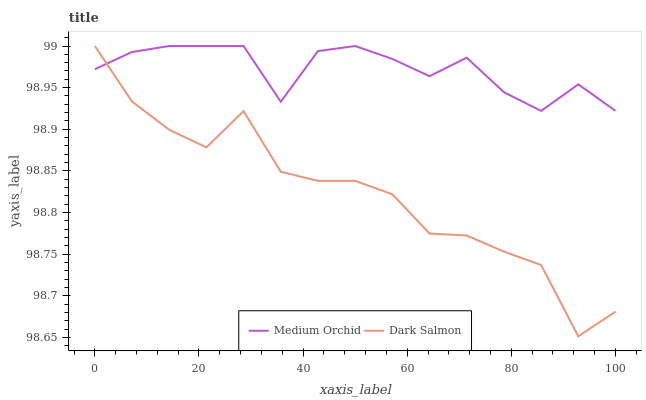Does Dark Salmon have the minimum area under the curve?
Answer yes or no. Yes. Does Medium Orchid have the maximum area under the curve?
Answer yes or no. Yes. Does Dark Salmon have the maximum area under the curve?
Answer yes or no. No. Is Medium Orchid the smoothest?
Answer yes or no. Yes. Is Dark Salmon the roughest?
Answer yes or no. Yes. Is Dark Salmon the smoothest?
Answer yes or no. No. Does Dark Salmon have the highest value?
Answer yes or no. Yes. Does Medium Orchid intersect Dark Salmon?
Answer yes or no. Yes. Is Medium Orchid less than Dark Salmon?
Answer yes or no. No. Is Medium Orchid greater than Dark Salmon?
Answer yes or no. No. 